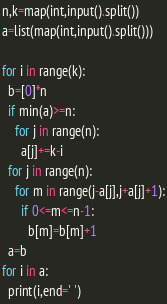<code> <loc_0><loc_0><loc_500><loc_500><_Python_>n,k=map(int,input().split())
a=list(map(int,input().split()))

for i in range(k):
  b=[0]*n
  if min(a)>=n:
    for j in range(n):
      a[j]+=k-i      
  for j in range(n):
    for m in range(j-a[j],j+a[j]+1):
      if 0<=m<=n-1:
        b[m]=b[m]+1
  a=b
for i in a:
  print(i,end=' ')</code> 